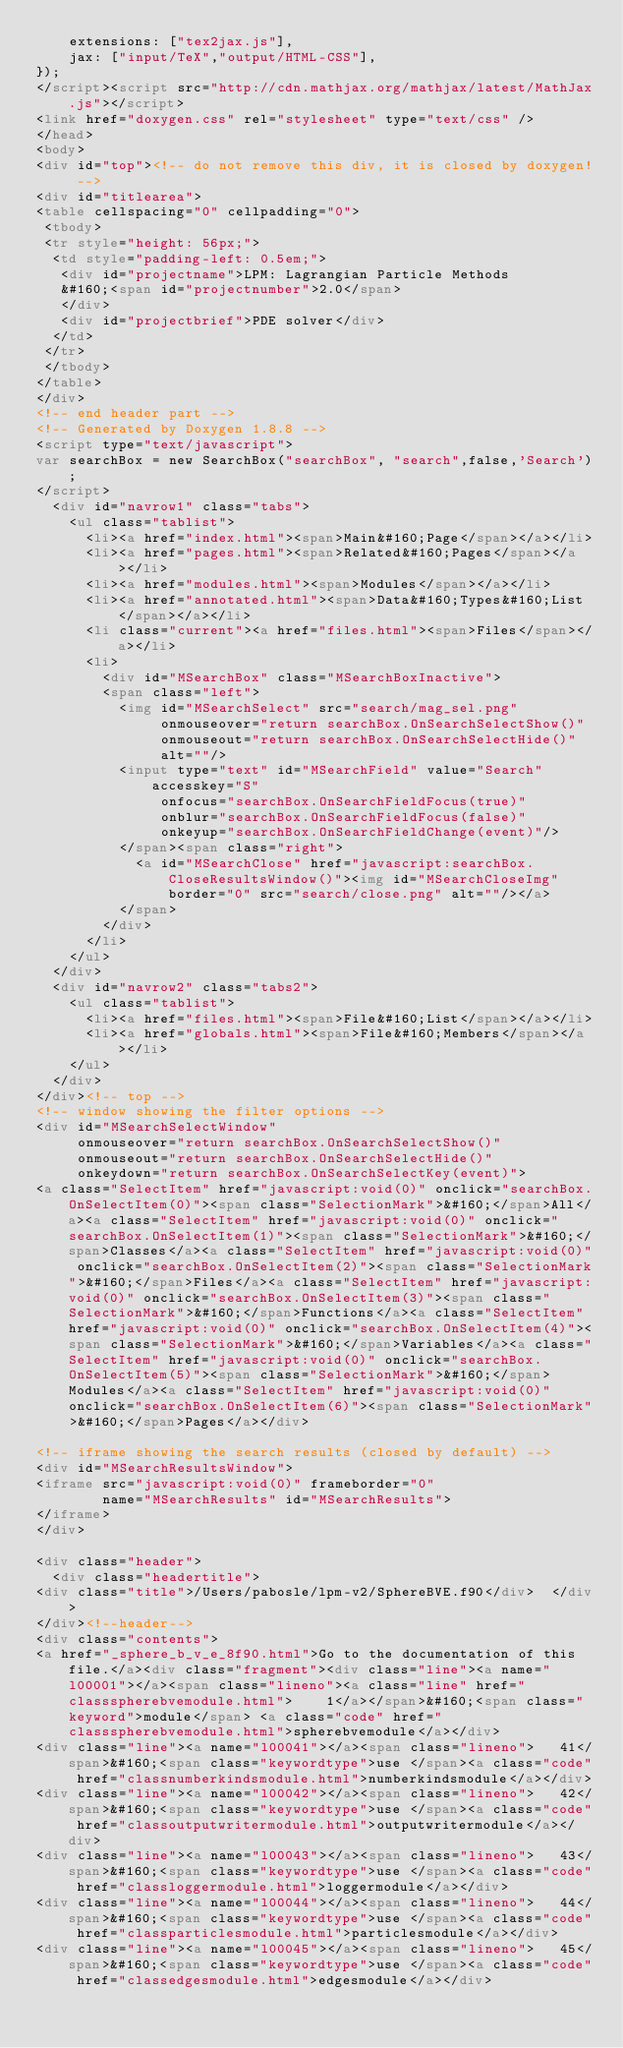Convert code to text. <code><loc_0><loc_0><loc_500><loc_500><_HTML_>    extensions: ["tex2jax.js"],
    jax: ["input/TeX","output/HTML-CSS"],
});
</script><script src="http://cdn.mathjax.org/mathjax/latest/MathJax.js"></script>
<link href="doxygen.css" rel="stylesheet" type="text/css" />
</head>
<body>
<div id="top"><!-- do not remove this div, it is closed by doxygen! -->
<div id="titlearea">
<table cellspacing="0" cellpadding="0">
 <tbody>
 <tr style="height: 56px;">
  <td style="padding-left: 0.5em;">
   <div id="projectname">LPM: Lagrangian Particle Methods
   &#160;<span id="projectnumber">2.0</span>
   </div>
   <div id="projectbrief">PDE solver</div>
  </td>
 </tr>
 </tbody>
</table>
</div>
<!-- end header part -->
<!-- Generated by Doxygen 1.8.8 -->
<script type="text/javascript">
var searchBox = new SearchBox("searchBox", "search",false,'Search');
</script>
  <div id="navrow1" class="tabs">
    <ul class="tablist">
      <li><a href="index.html"><span>Main&#160;Page</span></a></li>
      <li><a href="pages.html"><span>Related&#160;Pages</span></a></li>
      <li><a href="modules.html"><span>Modules</span></a></li>
      <li><a href="annotated.html"><span>Data&#160;Types&#160;List</span></a></li>
      <li class="current"><a href="files.html"><span>Files</span></a></li>
      <li>
        <div id="MSearchBox" class="MSearchBoxInactive">
        <span class="left">
          <img id="MSearchSelect" src="search/mag_sel.png"
               onmouseover="return searchBox.OnSearchSelectShow()"
               onmouseout="return searchBox.OnSearchSelectHide()"
               alt=""/>
          <input type="text" id="MSearchField" value="Search" accesskey="S"
               onfocus="searchBox.OnSearchFieldFocus(true)" 
               onblur="searchBox.OnSearchFieldFocus(false)" 
               onkeyup="searchBox.OnSearchFieldChange(event)"/>
          </span><span class="right">
            <a id="MSearchClose" href="javascript:searchBox.CloseResultsWindow()"><img id="MSearchCloseImg" border="0" src="search/close.png" alt=""/></a>
          </span>
        </div>
      </li>
    </ul>
  </div>
  <div id="navrow2" class="tabs2">
    <ul class="tablist">
      <li><a href="files.html"><span>File&#160;List</span></a></li>
      <li><a href="globals.html"><span>File&#160;Members</span></a></li>
    </ul>
  </div>
</div><!-- top -->
<!-- window showing the filter options -->
<div id="MSearchSelectWindow"
     onmouseover="return searchBox.OnSearchSelectShow()"
     onmouseout="return searchBox.OnSearchSelectHide()"
     onkeydown="return searchBox.OnSearchSelectKey(event)">
<a class="SelectItem" href="javascript:void(0)" onclick="searchBox.OnSelectItem(0)"><span class="SelectionMark">&#160;</span>All</a><a class="SelectItem" href="javascript:void(0)" onclick="searchBox.OnSelectItem(1)"><span class="SelectionMark">&#160;</span>Classes</a><a class="SelectItem" href="javascript:void(0)" onclick="searchBox.OnSelectItem(2)"><span class="SelectionMark">&#160;</span>Files</a><a class="SelectItem" href="javascript:void(0)" onclick="searchBox.OnSelectItem(3)"><span class="SelectionMark">&#160;</span>Functions</a><a class="SelectItem" href="javascript:void(0)" onclick="searchBox.OnSelectItem(4)"><span class="SelectionMark">&#160;</span>Variables</a><a class="SelectItem" href="javascript:void(0)" onclick="searchBox.OnSelectItem(5)"><span class="SelectionMark">&#160;</span>Modules</a><a class="SelectItem" href="javascript:void(0)" onclick="searchBox.OnSelectItem(6)"><span class="SelectionMark">&#160;</span>Pages</a></div>

<!-- iframe showing the search results (closed by default) -->
<div id="MSearchResultsWindow">
<iframe src="javascript:void(0)" frameborder="0" 
        name="MSearchResults" id="MSearchResults">
</iframe>
</div>

<div class="header">
  <div class="headertitle">
<div class="title">/Users/pabosle/lpm-v2/SphereBVE.f90</div>  </div>
</div><!--header-->
<div class="contents">
<a href="_sphere_b_v_e_8f90.html">Go to the documentation of this file.</a><div class="fragment"><div class="line"><a name="l00001"></a><span class="lineno"><a class="line" href="classspherebvemodule.html">    1</a></span>&#160;<span class="keyword">module</span> <a class="code" href="classspherebvemodule.html">spherebvemodule</a></div>
<div class="line"><a name="l00041"></a><span class="lineno">   41</span>&#160;<span class="keywordtype">use </span><a class="code" href="classnumberkindsmodule.html">numberkindsmodule</a></div>
<div class="line"><a name="l00042"></a><span class="lineno">   42</span>&#160;<span class="keywordtype">use </span><a class="code" href="classoutputwritermodule.html">outputwritermodule</a></div>
<div class="line"><a name="l00043"></a><span class="lineno">   43</span>&#160;<span class="keywordtype">use </span><a class="code" href="classloggermodule.html">loggermodule</a></div>
<div class="line"><a name="l00044"></a><span class="lineno">   44</span>&#160;<span class="keywordtype">use </span><a class="code" href="classparticlesmodule.html">particlesmodule</a></div>
<div class="line"><a name="l00045"></a><span class="lineno">   45</span>&#160;<span class="keywordtype">use </span><a class="code" href="classedgesmodule.html">edgesmodule</a></div></code> 